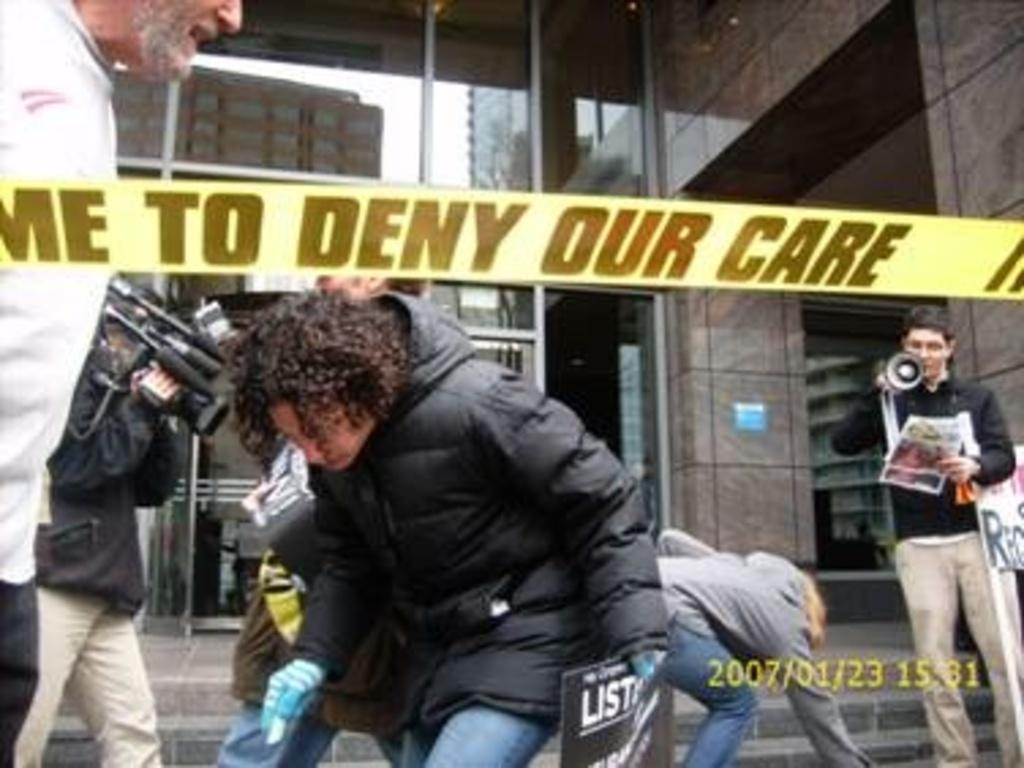How many people are in the image? There are persons in the image, but the exact number is not specified. What are the people in the image holding? One person is holding a camera, and another person is holding papers. What can be seen in the background of the image? There is a building in the background of the image. What type of fang can be seen in the image? There is no fang present in the image. How does the taste of the papers being held by the person affect the image? The taste of the papers is not relevant to the image, as they are not edible. 